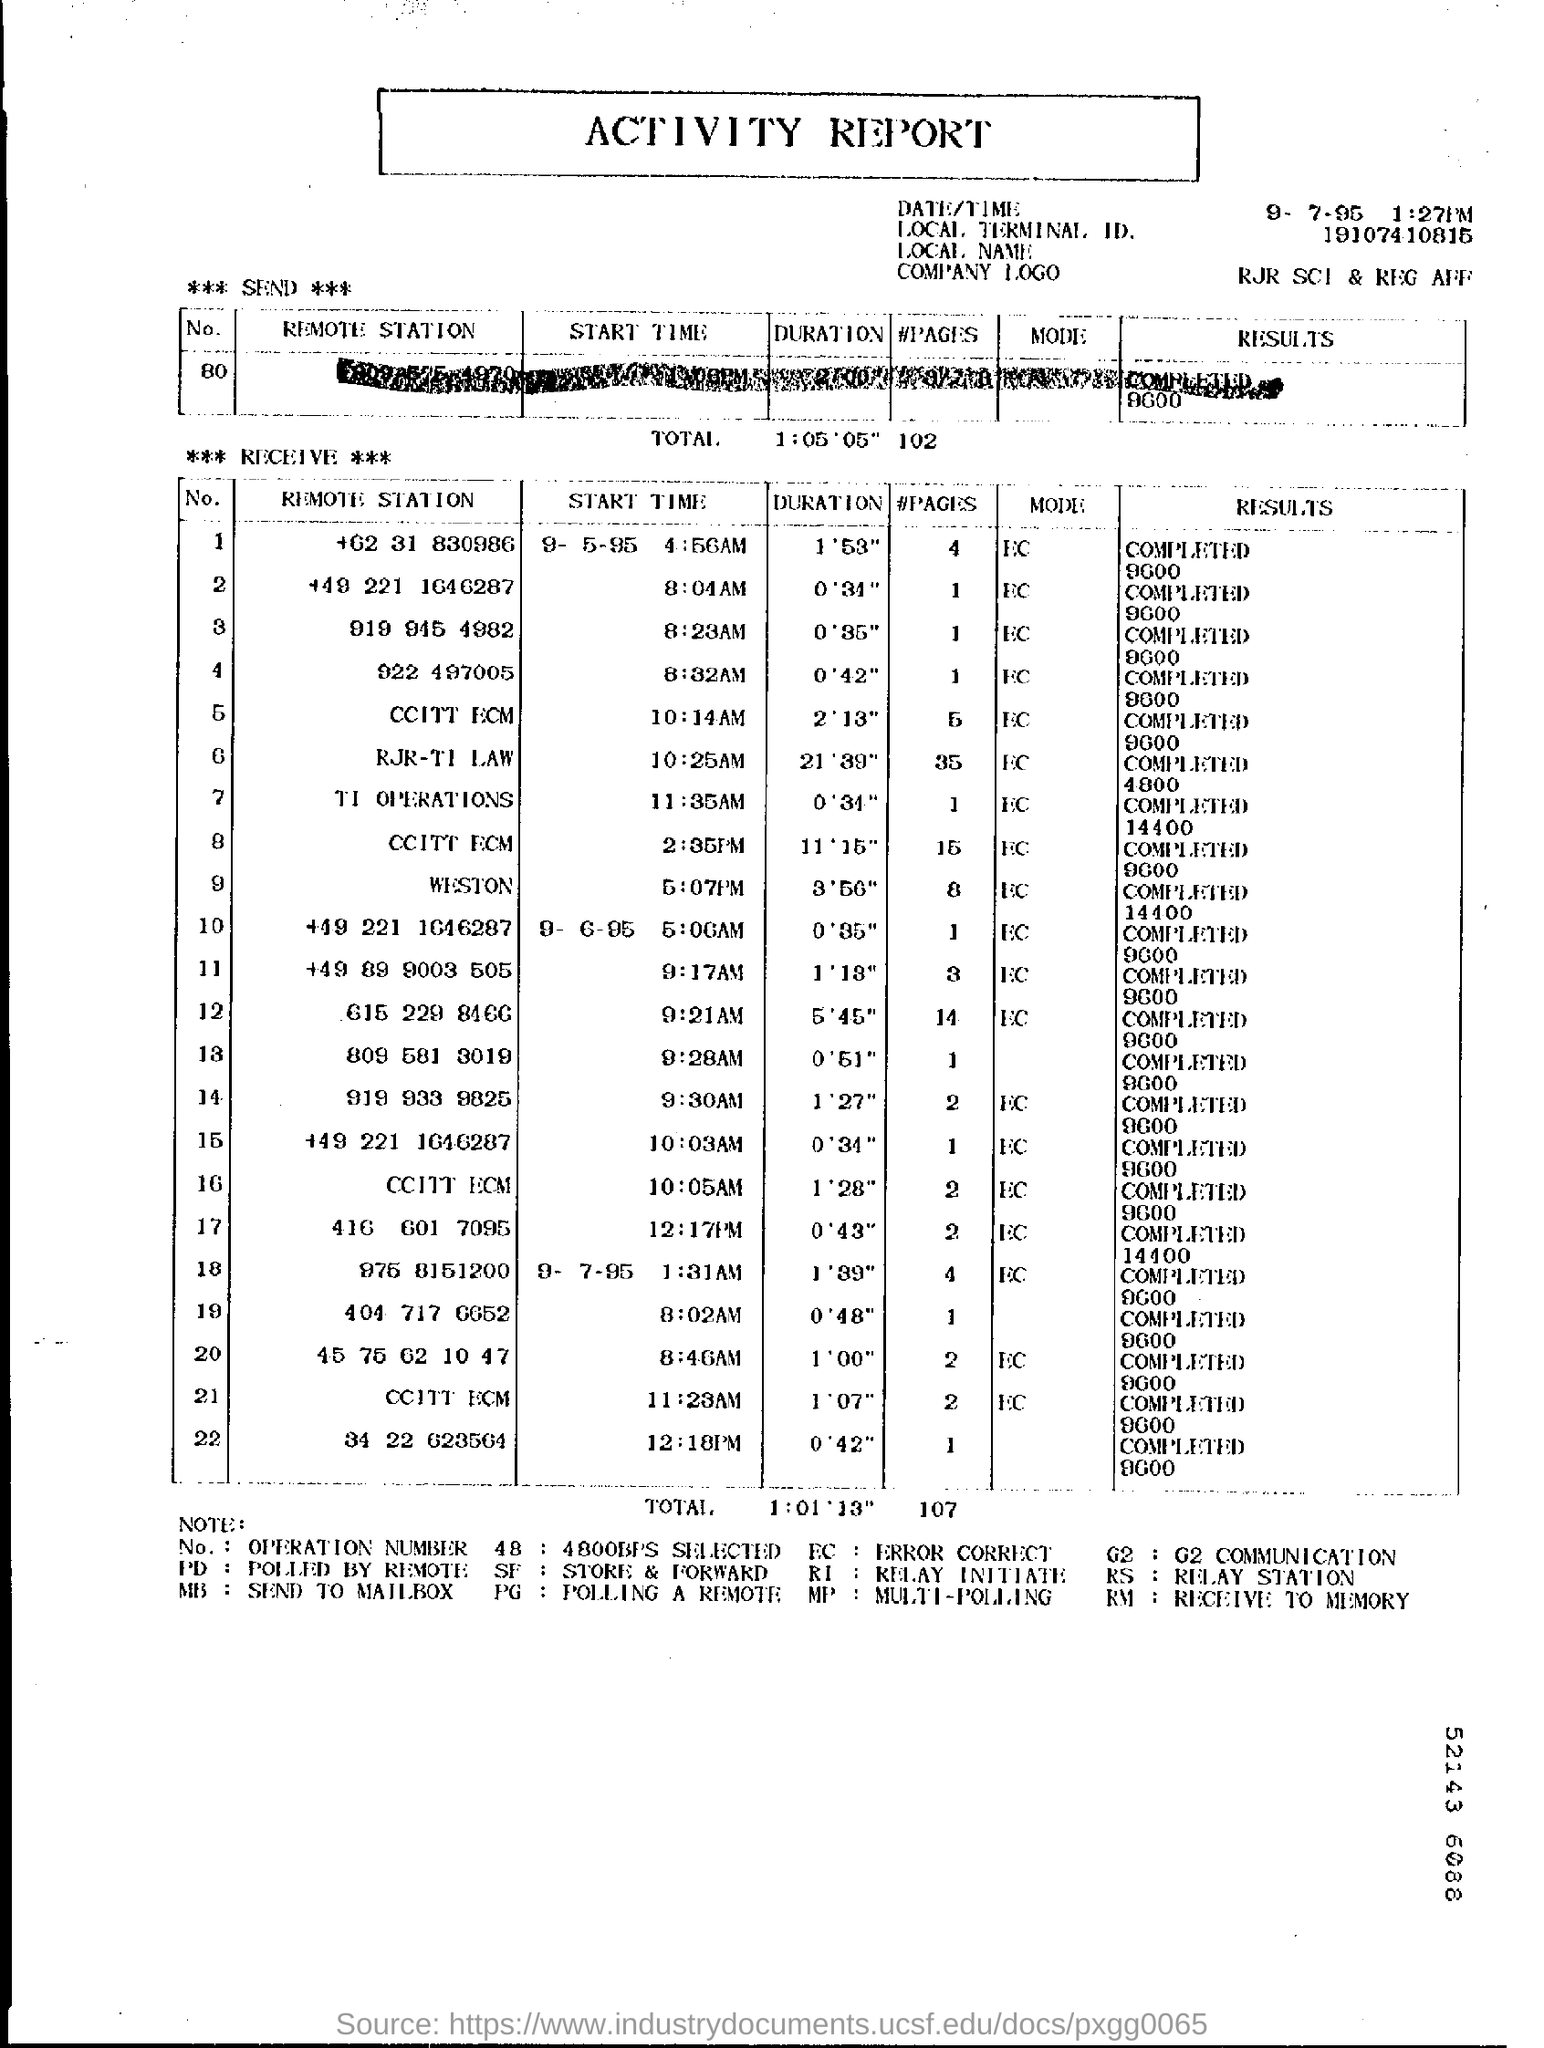Indicate a few pertinent items in this graphic. The date appears in the top-right corner of the report, and it is September 7, 1995. PG is the expansion of the string "POLLING A REMOTE... What does "MB" code stand for?" is a question that is asking for an explanation of the meaning of the letters "MB," which is a code that has not been specified or provided context for. It is also asking for this information to be sent to an individual's email address. The mode corresponding to number 1 is EC. The time mentioned at the right top corner of the report is 1:27pm. 